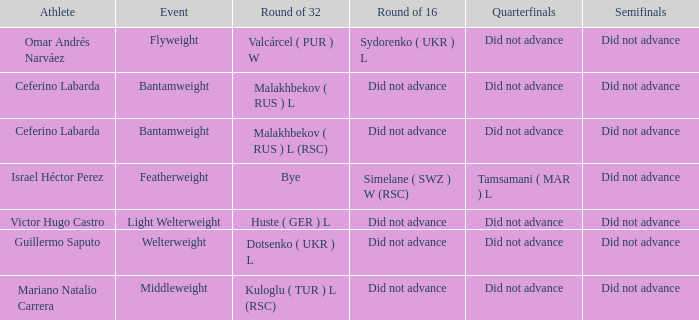When a bye took place in the round of 32, what was the result in the round of 16? Did not advance. 